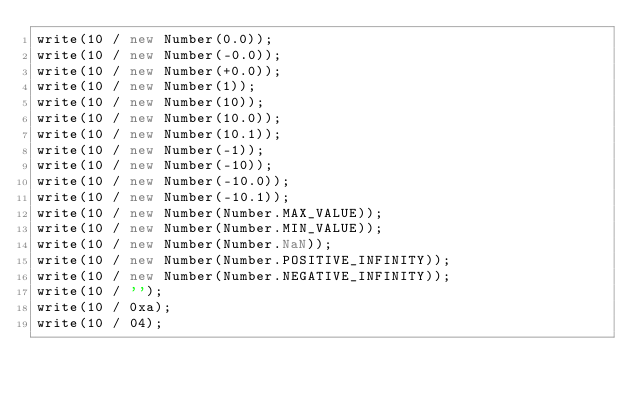<code> <loc_0><loc_0><loc_500><loc_500><_JavaScript_>write(10 / new Number(0.0));
write(10 / new Number(-0.0));
write(10 / new Number(+0.0));
write(10 / new Number(1));
write(10 / new Number(10));
write(10 / new Number(10.0));
write(10 / new Number(10.1));
write(10 / new Number(-1));
write(10 / new Number(-10));
write(10 / new Number(-10.0));
write(10 / new Number(-10.1));
write(10 / new Number(Number.MAX_VALUE));
write(10 / new Number(Number.MIN_VALUE));
write(10 / new Number(Number.NaN));
write(10 / new Number(Number.POSITIVE_INFINITY));
write(10 / new Number(Number.NEGATIVE_INFINITY));
write(10 / '');
write(10 / 0xa);
write(10 / 04);</code> 